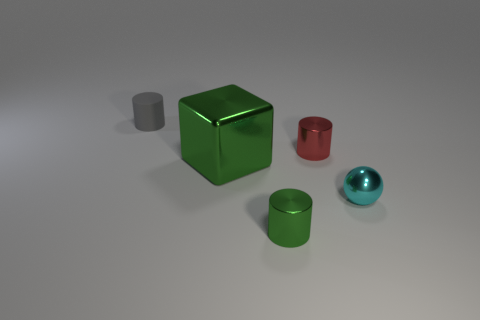Subtract all small green metal cylinders. How many cylinders are left? 2 Subtract 1 cylinders. How many cylinders are left? 2 Add 1 large yellow metal cubes. How many objects exist? 6 Subtract all cylinders. How many objects are left? 2 Subtract all green cylinders. Subtract all brown blocks. How many cylinders are left? 2 Subtract all metallic things. Subtract all tiny cyan metallic things. How many objects are left? 0 Add 5 small cyan balls. How many small cyan balls are left? 6 Add 3 tiny red rubber cylinders. How many tiny red rubber cylinders exist? 3 Subtract 0 yellow cubes. How many objects are left? 5 